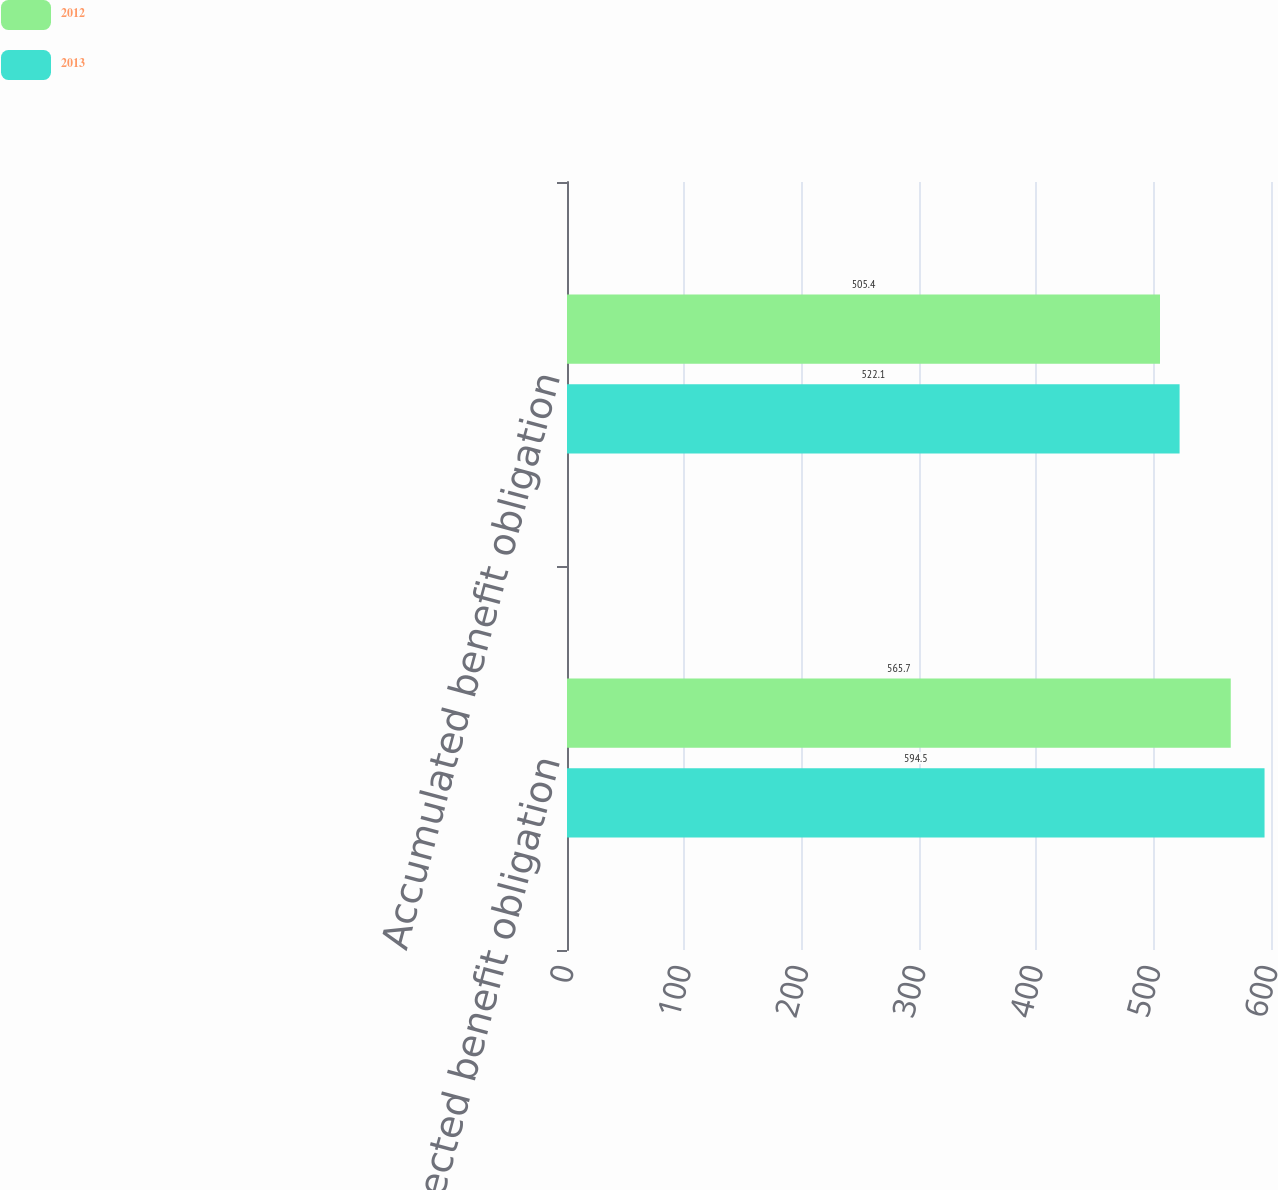Convert chart to OTSL. <chart><loc_0><loc_0><loc_500><loc_500><stacked_bar_chart><ecel><fcel>Projected benefit obligation<fcel>Accumulated benefit obligation<nl><fcel>2012<fcel>565.7<fcel>505.4<nl><fcel>2013<fcel>594.5<fcel>522.1<nl></chart> 